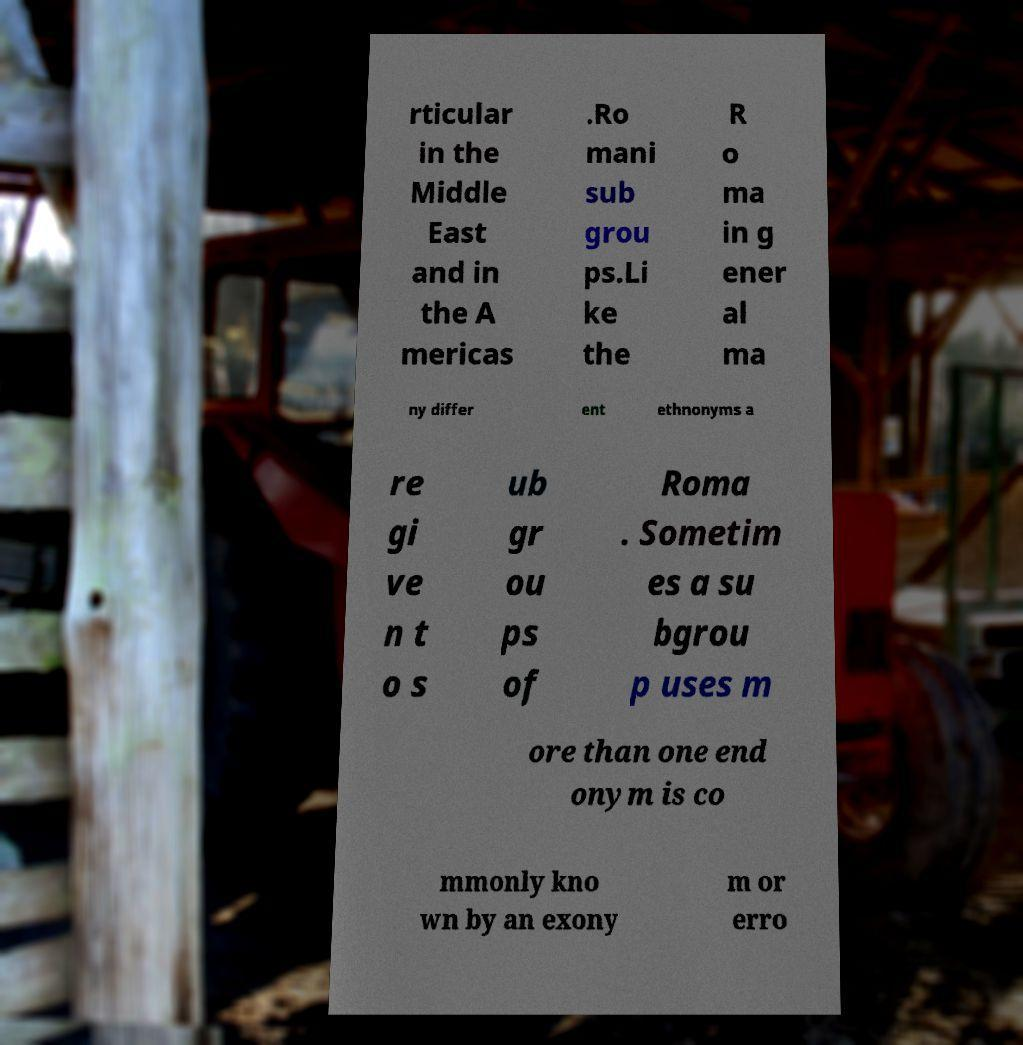For documentation purposes, I need the text within this image transcribed. Could you provide that? rticular in the Middle East and in the A mericas .Ro mani sub grou ps.Li ke the R o ma in g ener al ma ny differ ent ethnonyms a re gi ve n t o s ub gr ou ps of Roma . Sometim es a su bgrou p uses m ore than one end onym is co mmonly kno wn by an exony m or erro 